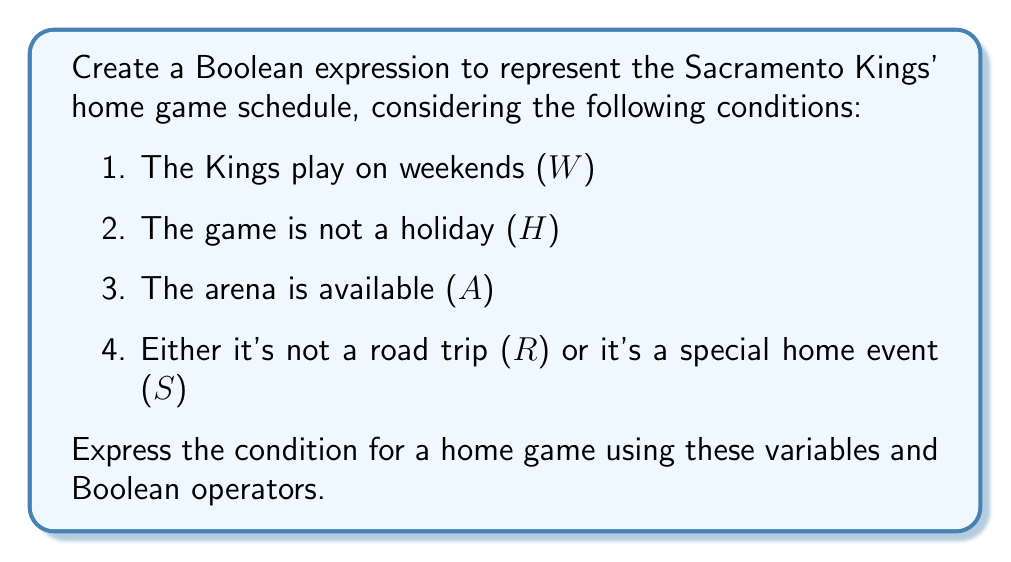Can you solve this math problem? Let's break this down step-by-step:

1. The Kings play on weekends: W

2. The game is not a holiday: $\neg$H (we use the NOT operator)

3. The arena is available: A

4. Either it's not a road trip or it's a special home event: $\neg$R $\lor$ S (we use the OR operator)

Now, to have a home game, all these conditions must be true simultaneously. In Boolean algebra, we use the AND operator ($\land$) to represent this.

So, our expression becomes:

$$ W \land (\neg H) \land A \land (\neg R \lor S) $$

This expression reads as:
"It's a weekend AND not a holiday AND the arena is available AND (it's not a road trip OR it's a special home event)"

If all these conditions are met (the expression evaluates to true), then there's a home game scheduled.
Answer: $W \land (\neg H) \land A \land (\neg R \lor S)$ 